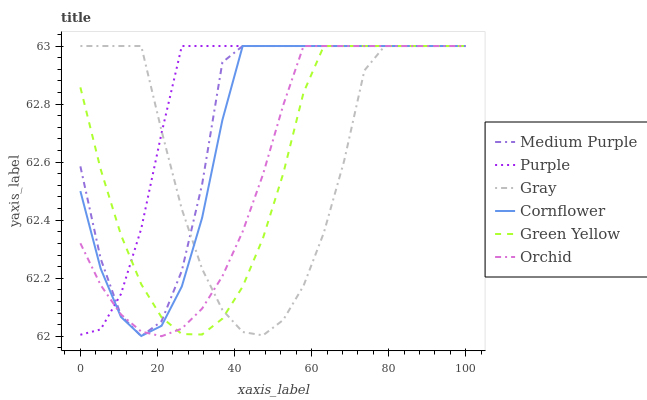Does Orchid have the minimum area under the curve?
Answer yes or no. Yes. Does Purple have the maximum area under the curve?
Answer yes or no. Yes. Does Gray have the minimum area under the curve?
Answer yes or no. No. Does Gray have the maximum area under the curve?
Answer yes or no. No. Is Orchid the smoothest?
Answer yes or no. Yes. Is Gray the roughest?
Answer yes or no. Yes. Is Purple the smoothest?
Answer yes or no. No. Is Purple the roughest?
Answer yes or no. No. Does Orchid have the lowest value?
Answer yes or no. Yes. Does Gray have the lowest value?
Answer yes or no. No. Does Orchid have the highest value?
Answer yes or no. Yes. Does Purple intersect Medium Purple?
Answer yes or no. Yes. Is Purple less than Medium Purple?
Answer yes or no. No. Is Purple greater than Medium Purple?
Answer yes or no. No. 